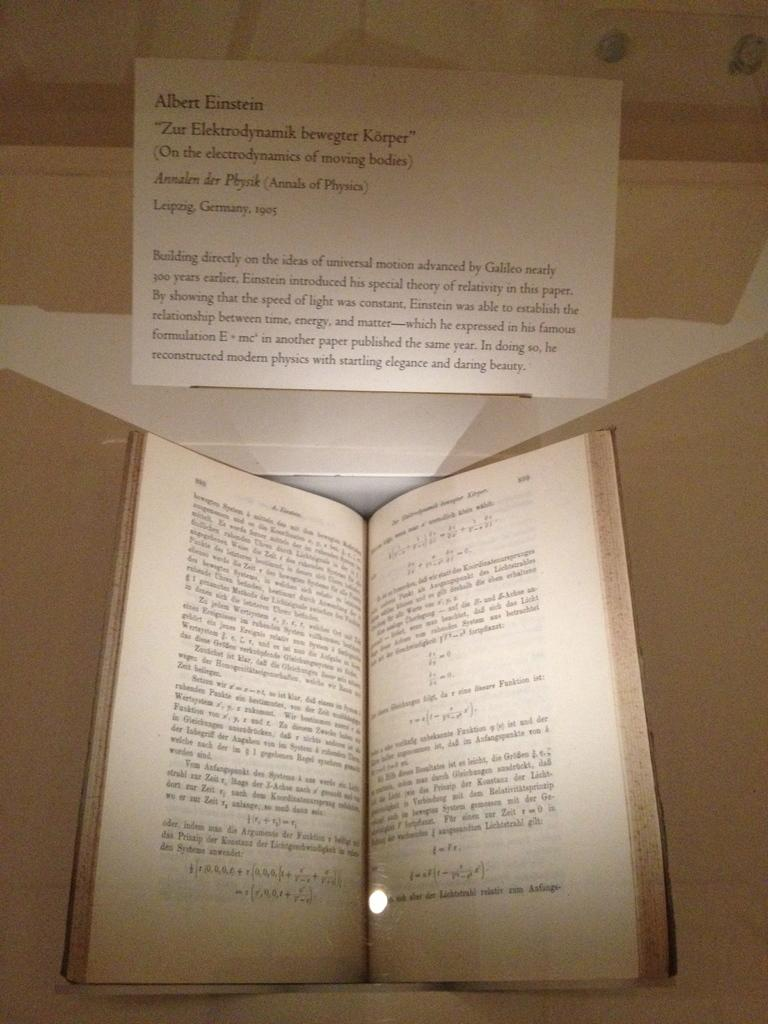Provide a one-sentence caption for the provided image. a card above an open book that says 'albert einstein' on it. 